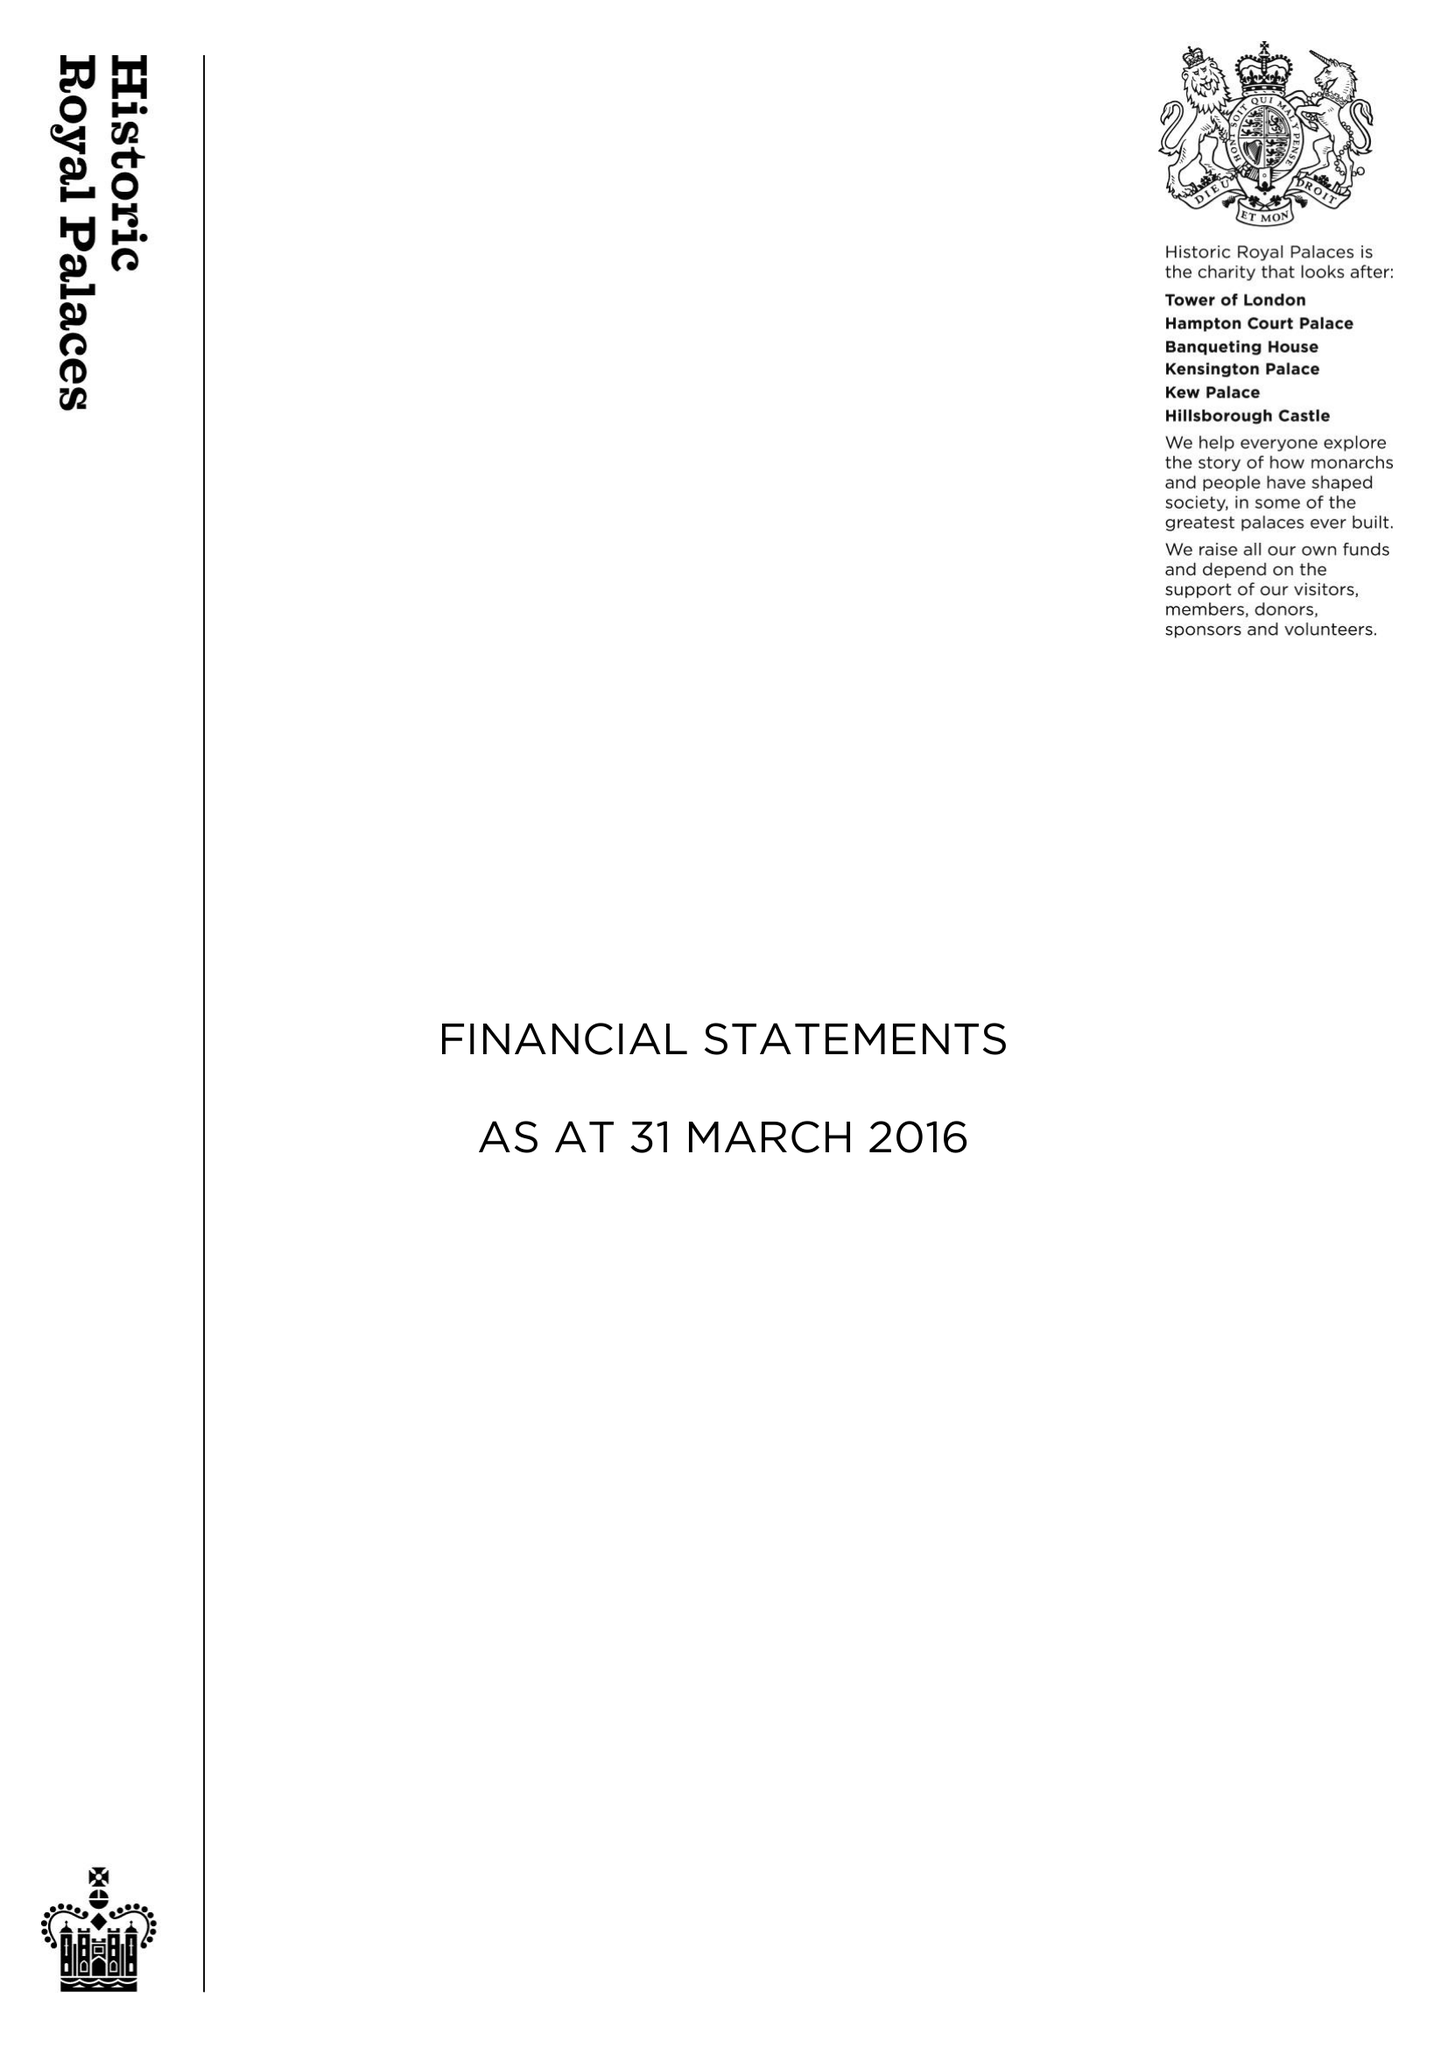What is the value for the charity_number?
Answer the question using a single word or phrase. 1068852 